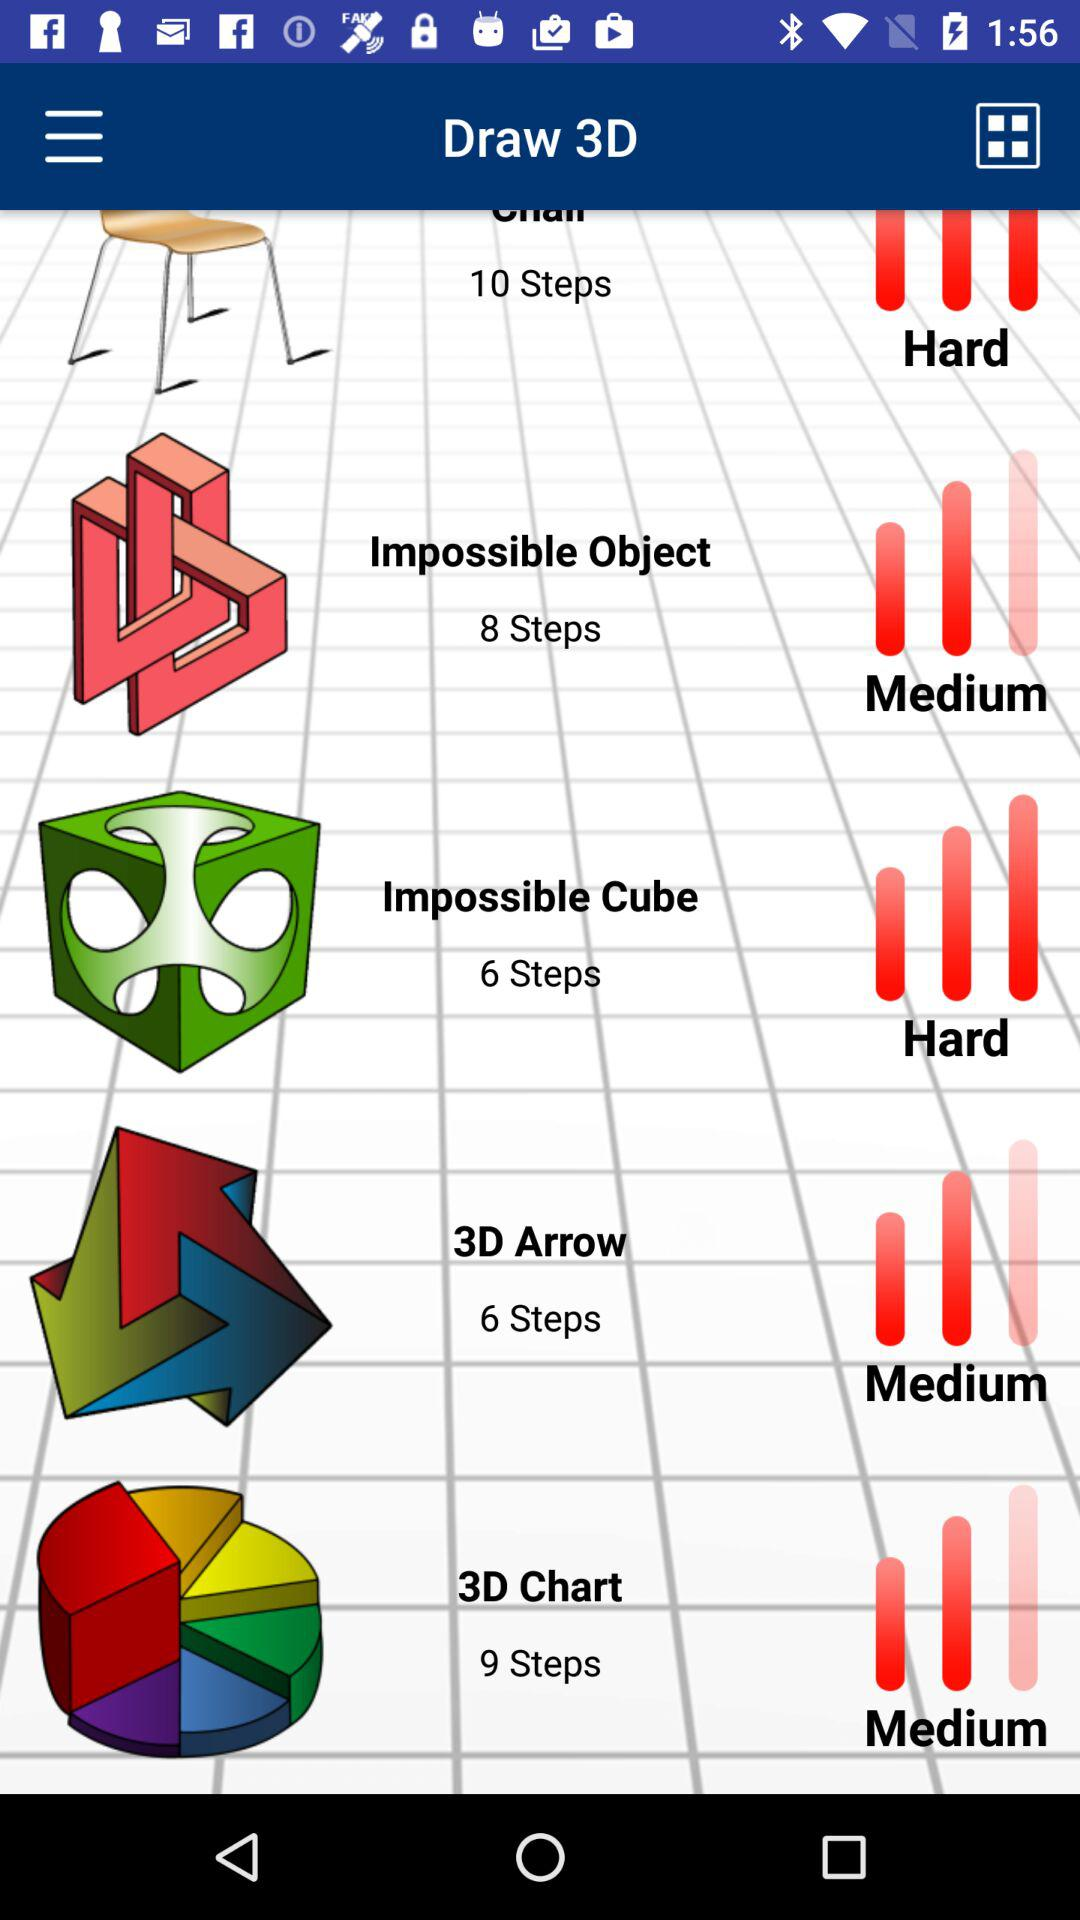Which drawing has 8 steps? The drawing of the impossible object has 8 steps. 